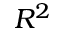Convert formula to latex. <formula><loc_0><loc_0><loc_500><loc_500>R ^ { 2 }</formula> 